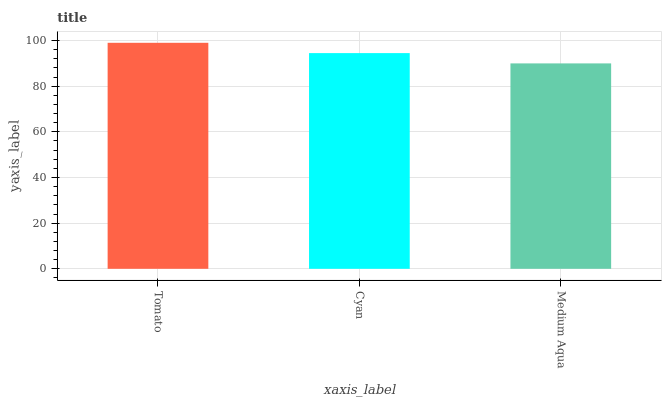Is Medium Aqua the minimum?
Answer yes or no. Yes. Is Tomato the maximum?
Answer yes or no. Yes. Is Cyan the minimum?
Answer yes or no. No. Is Cyan the maximum?
Answer yes or no. No. Is Tomato greater than Cyan?
Answer yes or no. Yes. Is Cyan less than Tomato?
Answer yes or no. Yes. Is Cyan greater than Tomato?
Answer yes or no. No. Is Tomato less than Cyan?
Answer yes or no. No. Is Cyan the high median?
Answer yes or no. Yes. Is Cyan the low median?
Answer yes or no. Yes. Is Tomato the high median?
Answer yes or no. No. Is Tomato the low median?
Answer yes or no. No. 